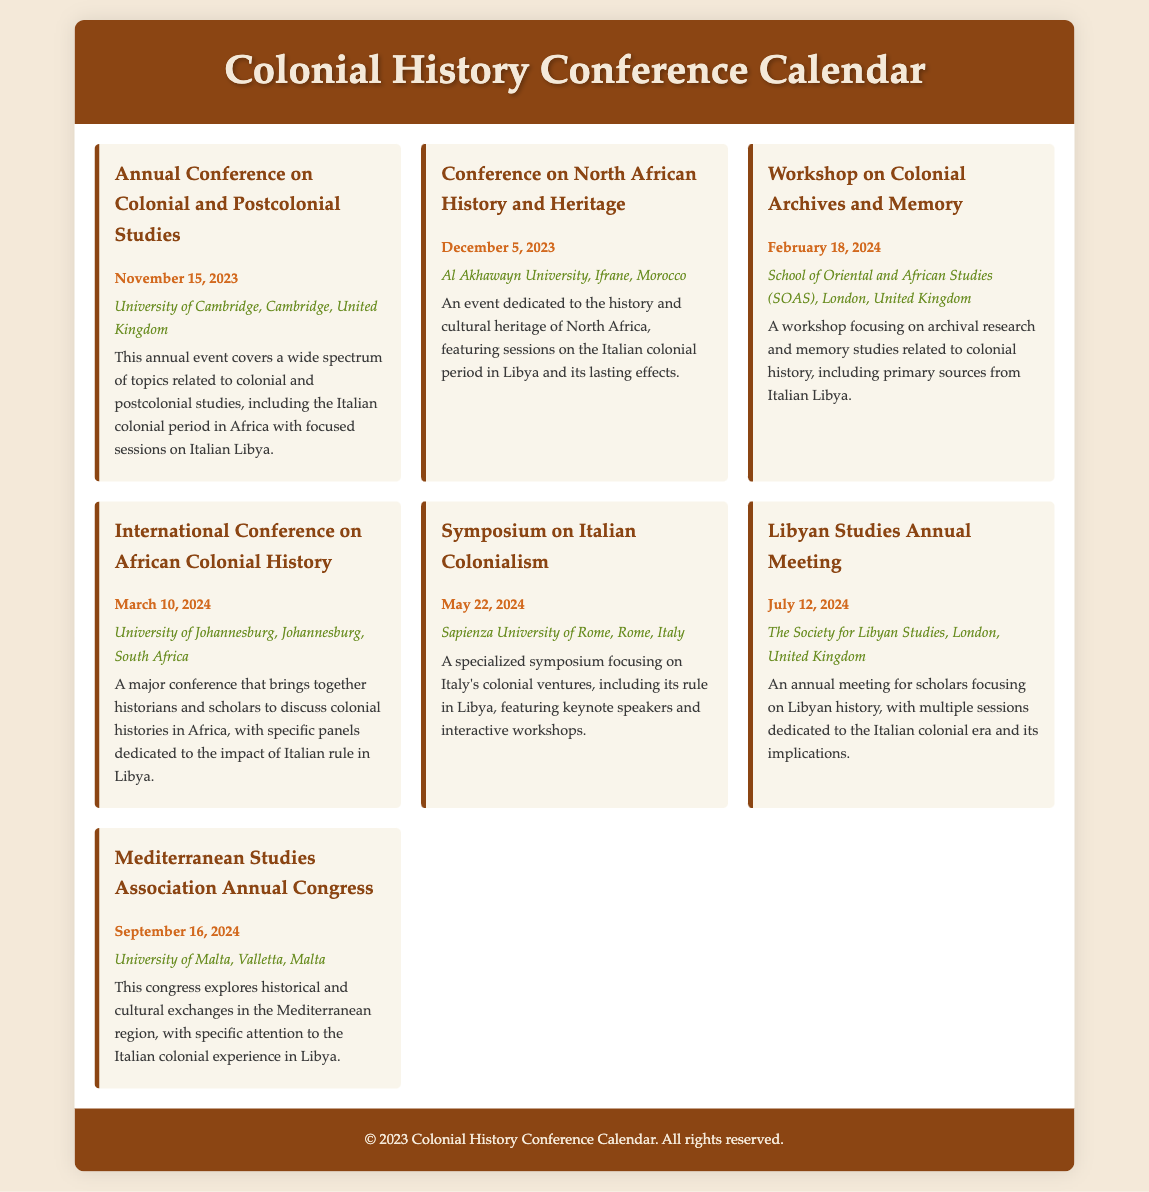What is the date of the Annual Conference on Colonial and Postcolonial Studies? The document specifies that this conference is scheduled for November 15, 2023.
Answer: November 15, 2023 Where is the Conference on North African History and Heritage held? According to the document, this conference takes place at Al Akhawayn University, Ifrane, Morocco.
Answer: Al Akhawayn University, Ifrane, Morocco What is the focus of the Workshop on Colonial Archives and Memory? The document mentions that this workshop will focus on archival research and memory studies related to colonial history.
Answer: Archival research and memory studies Which event occurs in May 2024? The document lists the Symposium on Italian Colonialism as taking place on May 22, 2024.
Answer: Symposium on Italian Colonialism How many events are scheduled for the first half of 2024? By examining the document, we see there are three events scheduled before July 2024: one in February, one in March, and one in May.
Answer: Three What is the location of the Libyan Studies Annual Meeting? The document states that the annual meeting is held by The Society for Libyan Studies in London, United Kingdom.
Answer: The Society for Libyan Studies, London, United Kingdom What type of study does the Mediterranean Studies Association Annual Congress explore? The document indicates that this congress explores historical and cultural exchanges in the Mediterranean region.
Answer: Historical and cultural exchanges Which conference features sessions on the Italian colonial period in Libya? The document highlights multiple conferences that feature sessions on this topic, with the Conference on North African History and Heritage specifically noted.
Answer: Conference on North African History and Heritage 